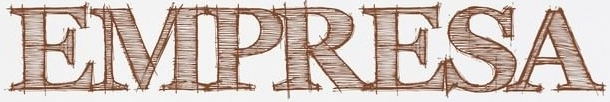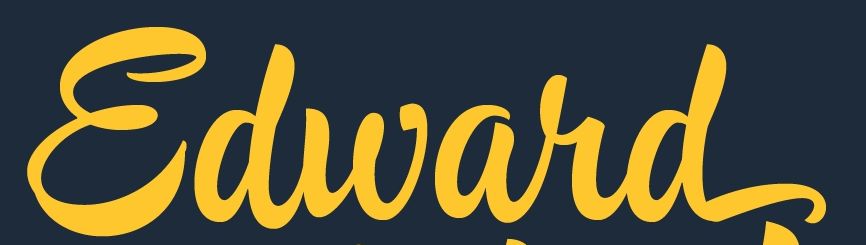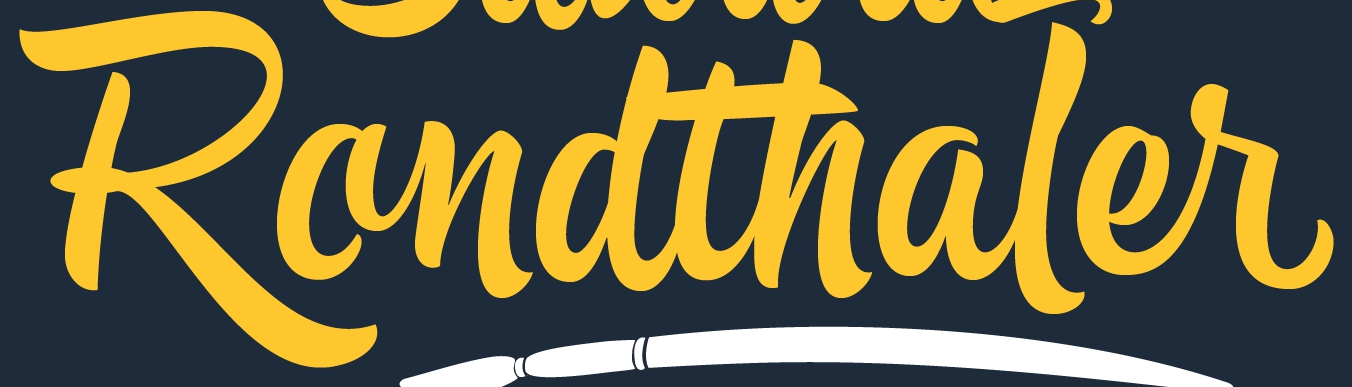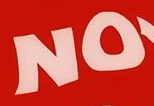What words are shown in these images in order, separated by a semicolon? EMPRESA; Edward; Randthaler; NO 